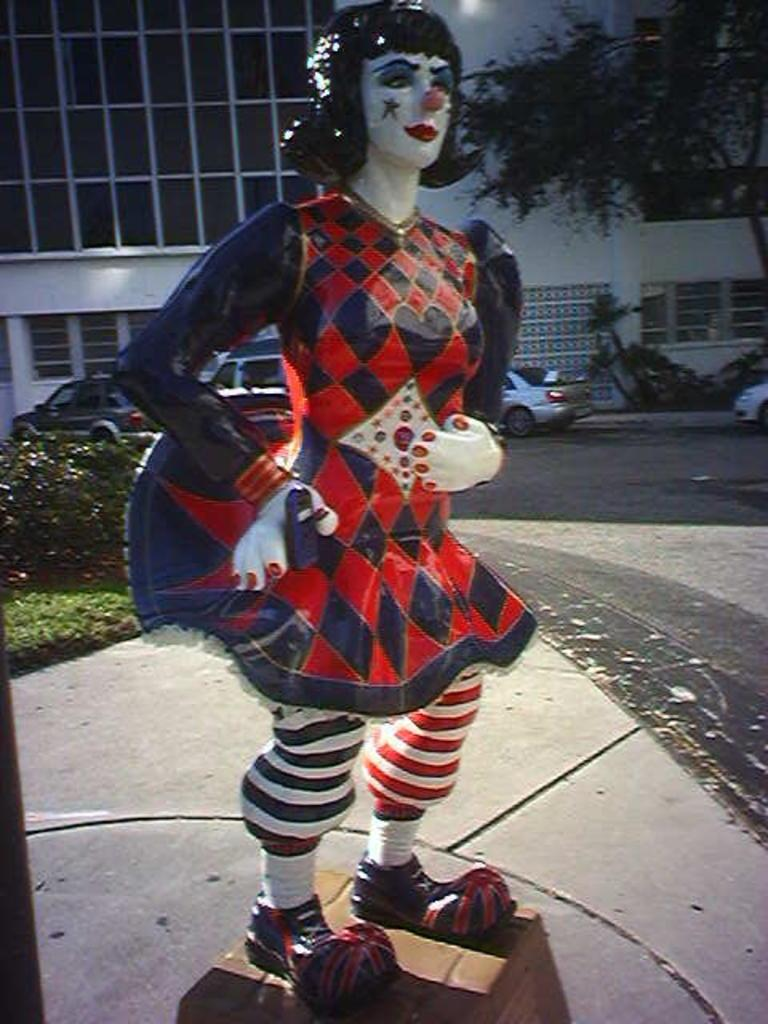What is located in the foreground of the image? There is a toy in the foreground of the image. What can be seen in the background of the image? Buildings, trees, vehicles, plants, and grass are visible in the background of the image. What type of surface is at the bottom of the image? There is a road at the bottom of the image. What type of cabbage can be seen growing on the side of the road in the image? There is no cabbage present in the image; the focus is on the toy in the foreground and the various elements in the background. What is the effect of the pail on the toy in the image? There is no pail present in the image, so it cannot have any effect on the toy. 